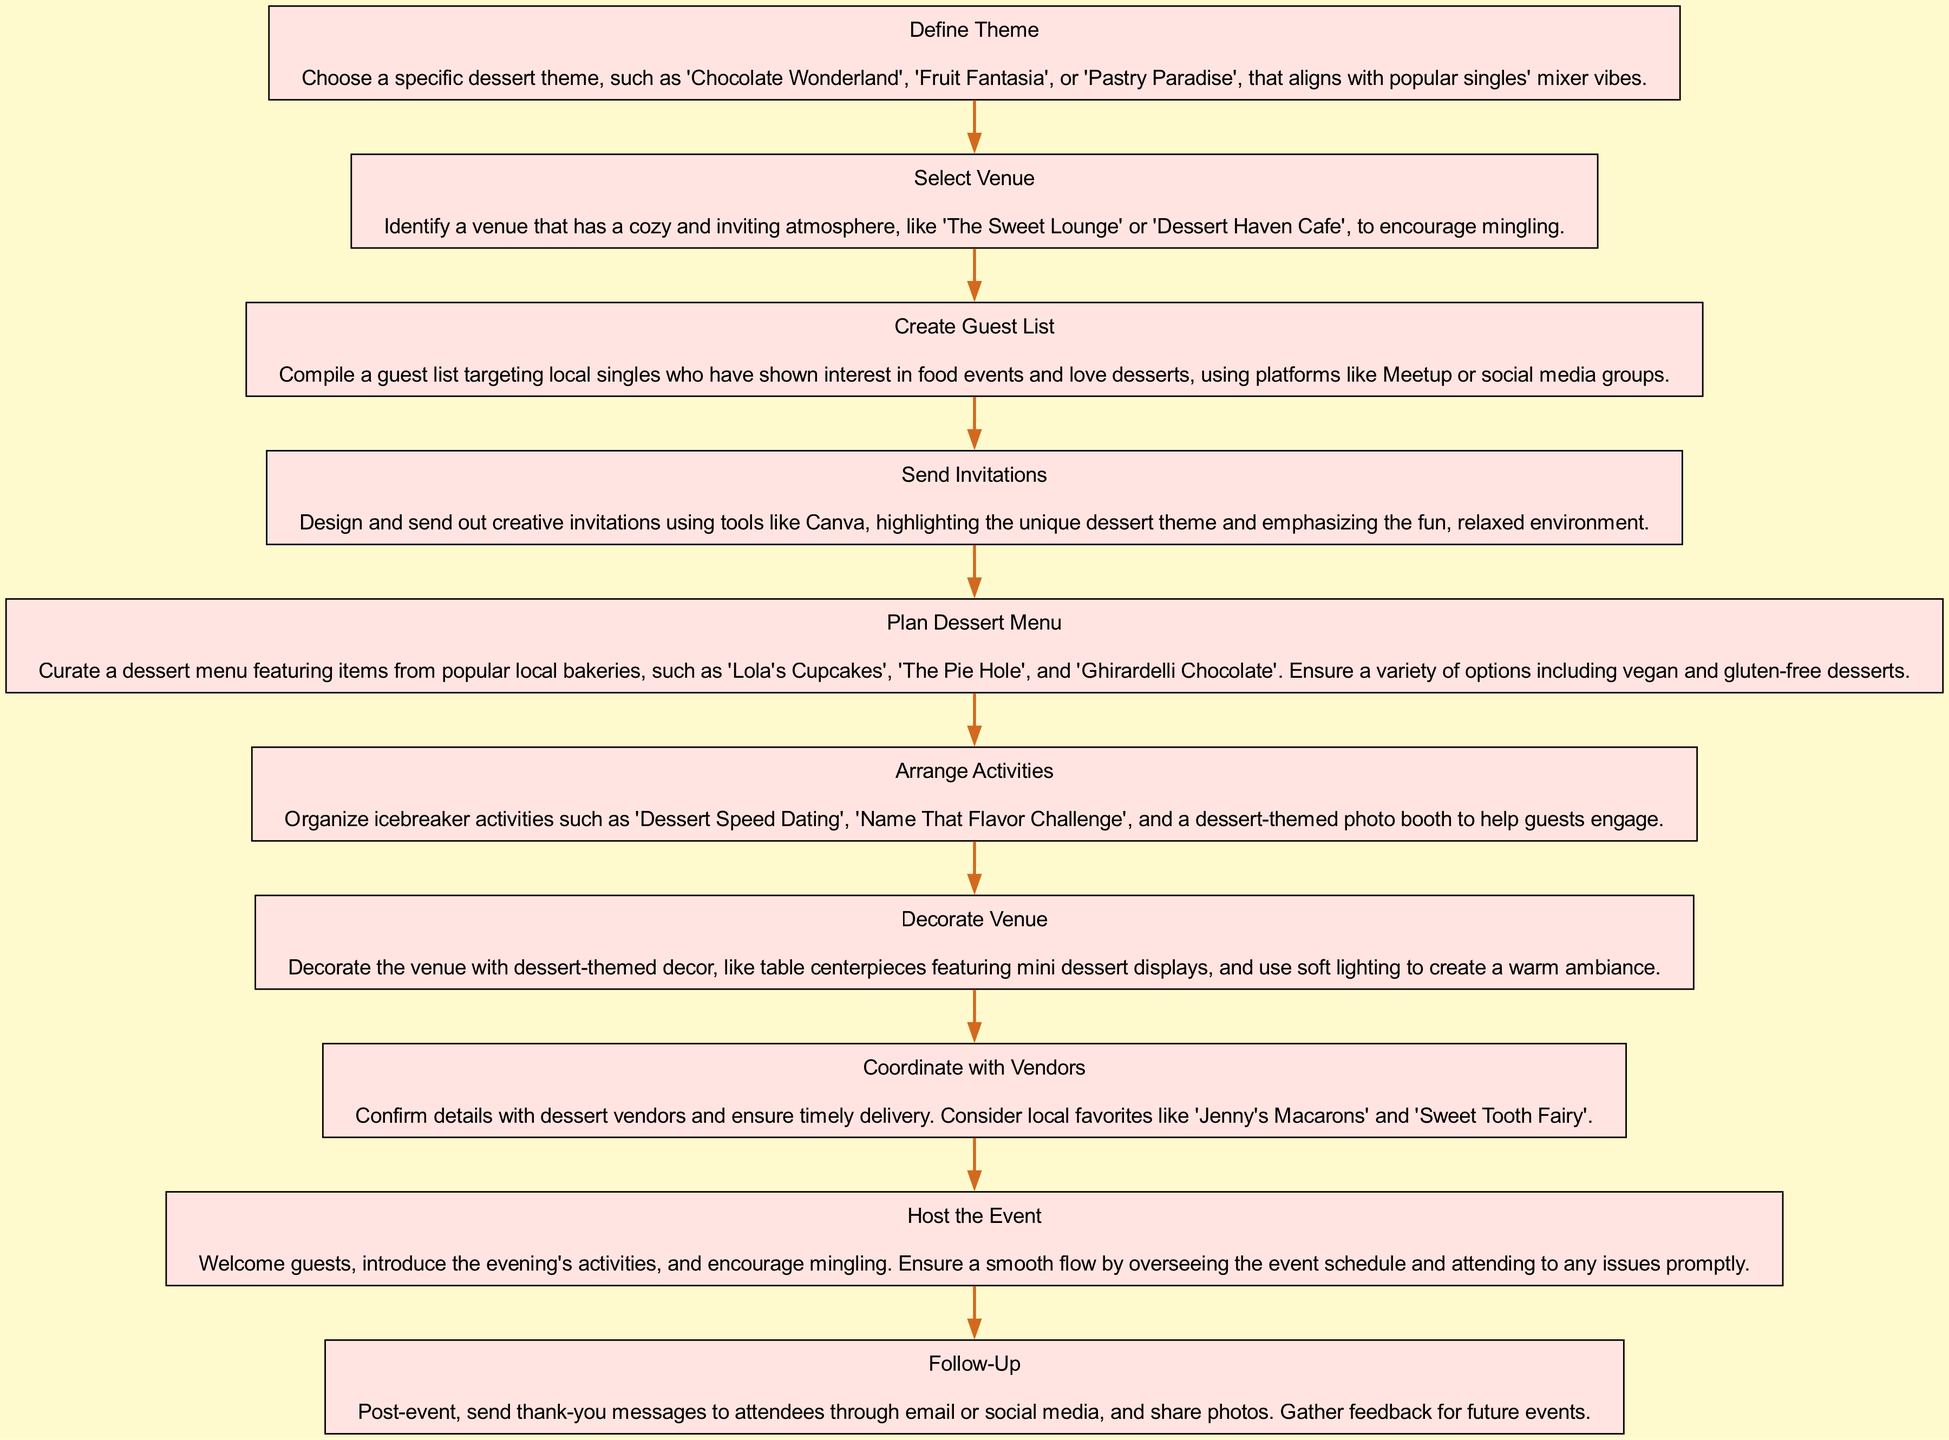What is the first step in the diagram? The first step listed in the flow chart is "Define Theme". This can be identified as it is the topmost node in the flow of steps.
Answer: Define Theme How many nodes are in the diagram? By counting each individual step represented as a node, we find that there are a total of 10 steps in the diagram, which correspond to 10 nodes.
Answer: 10 What is the last step in the sequence? The last step in the diagram is "Follow-Up", which is located at the bottom of the sequence and concludes the planning process.
Answer: Follow-Up What do you need to do after sending invitations? After sending invitations, the next step is to "Plan Dessert Menu". This can be seen as a progression in the flow when moving from one action to another.
Answer: Plan Dessert Menu What should be done after you host the event? After hosting the event, the subsequent action is "Follow-Up", which involves engaging attendees post-event and gathering feedback. This step naturally follows in the flow of the diagram.
Answer: Follow-Up Which step involves confirming details with dessert vendors? The step labeled "Coordinate with Vendors" specifically addresses the action of confirming vendor details to ensure everything is in order for the event. This is a key aspect of logistical planning and appears distinctly in the chart.
Answer: Coordinate with Vendors Which activity is suggested for guest engagement? "Dessert Speed Dating" is one of the activities organized to enhance guest engagement, as highlighted in the flow diagram where activities are arranged for fun interactions.
Answer: Dessert Speed Dating What type of decor is suggested for the venue? The diagram suggests using "dessert-themed decor", emphasizing that the decorations should reflect the overall theme of the event, which is central to creating the desired atmosphere.
Answer: Dessert-themed decor 